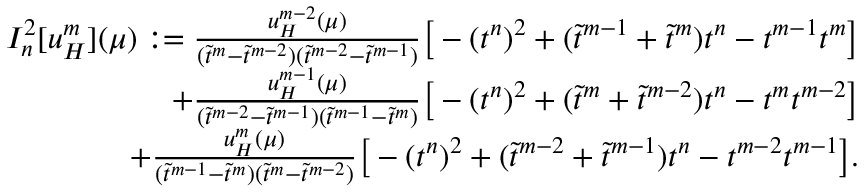<formula> <loc_0><loc_0><loc_500><loc_500>\begin{array} { r } { I _ { n } ^ { 2 } [ u _ { H } ^ { m } ] ( \mu ) \colon = \frac { u _ { H } ^ { m - 2 } ( \mu ) } { ( \widetilde { t } ^ { m } - \widetilde { t } ^ { m - 2 } ) ( \widetilde { t } ^ { m - 2 } - \widetilde { t } ^ { m - 1 } ) } \left [ - ( t ^ { n } ) ^ { 2 } + ( \widetilde { t } ^ { m - 1 } + \widetilde { t } ^ { m } ) t ^ { n } - t ^ { m - 1 } t ^ { m } \right ] } \\ { + \frac { u _ { H } ^ { m - 1 } ( \mu ) } { ( \widetilde { t } ^ { m - 2 } - \widetilde { t } ^ { m - 1 } ) ( \widetilde { t } ^ { m - 1 } - \widetilde { t } ^ { m } ) } \left [ - ( t ^ { n } ) ^ { 2 } + ( \widetilde { t } ^ { m } + \widetilde { t } ^ { m - 2 } ) t ^ { n } - t ^ { m } t ^ { m - 2 } \right ] } \\ { + \frac { u _ { H } ^ { m } ( \mu ) } { ( \widetilde { t } ^ { m - 1 } - \widetilde { t } ^ { m } ) ( \widetilde { t } ^ { m } - \widetilde { t } ^ { m - 2 } ) } \left [ - ( t ^ { n } ) ^ { 2 } + ( \widetilde { t } ^ { m - 2 } + \widetilde { t } ^ { m - 1 } ) t ^ { n } - t ^ { m - 2 } t ^ { m - 1 } \right ] . } \end{array}</formula> 